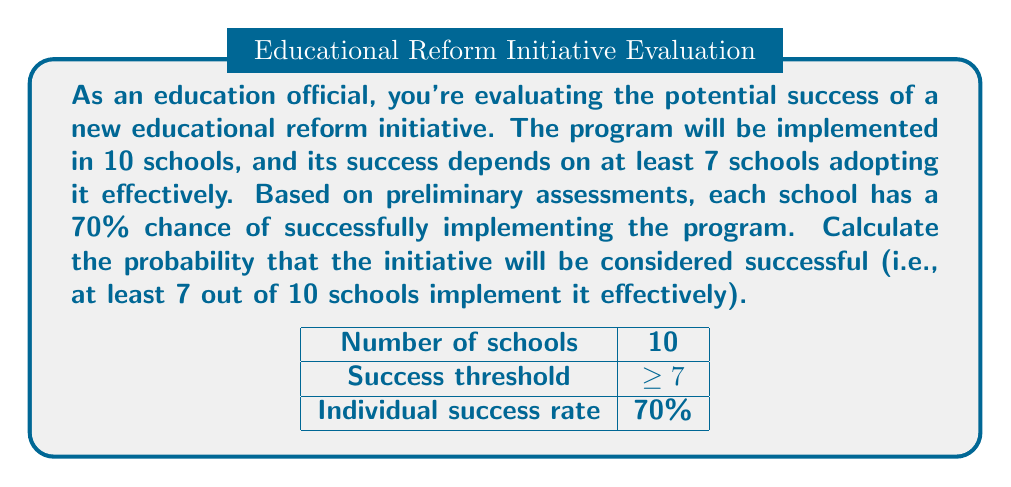Show me your answer to this math problem. Let's approach this step-by-step using combinatorics and probability theory:

1) This scenario follows a binomial probability distribution, where we have:
   - n = 10 (total number of schools)
   - p = 0.70 (probability of success for each school)
   - We need to find P(X ≥ 7), where X is the number of successful implementations

2) The probability of at least 7 successes is equal to the sum of probabilities of exactly 7, 8, 9, or 10 successes:

   P(X ≥ 7) = P(X = 7) + P(X = 8) + P(X = 9) + P(X = 10)

3) For each case, we use the binomial probability formula:

   $$P(X = k) = \binom{n}{k} p^k (1-p)^{n-k}$$

4) Let's calculate each probability:

   P(X = 7) = $\binom{10}{7} (0.70)^7 (0.30)^3 = 120 \cdot 0.0824 \cdot 0.027 = 0.2668$

   P(X = 8) = $\binom{10}{8} (0.70)^8 (0.30)^2 = 45 \cdot 0.1176 \cdot 0.09 = 0.2369$

   P(X = 9) = $\binom{10}{9} (0.70)^9 (0.30)^1 = 10 \cdot 0.1680 \cdot 0.3 = 0.0504$

   P(X = 10) = $\binom{10}{10} (0.70)^{10} (0.30)^0 = 1 \cdot 0.2824 \cdot 1 = 0.0282$

5) Sum these probabilities:

   P(X ≥ 7) = 0.2668 + 0.2369 + 0.0504 + 0.0282 = 0.5823

Therefore, the probability that the initiative will be considered successful is approximately 0.5823 or 58.23%.
Answer: 0.5823 (or 58.23%) 